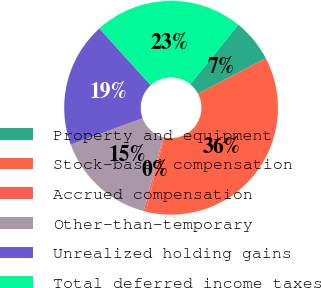Convert chart. <chart><loc_0><loc_0><loc_500><loc_500><pie_chart><fcel>Property and equipment<fcel>Stock-based compensation<fcel>Accrued compensation<fcel>Other-than-temporary<fcel>Unrealized holding gains<fcel>Total deferred income taxes<nl><fcel>6.51%<fcel>36.45%<fcel>0.33%<fcel>15.29%<fcel>18.91%<fcel>22.52%<nl></chart> 